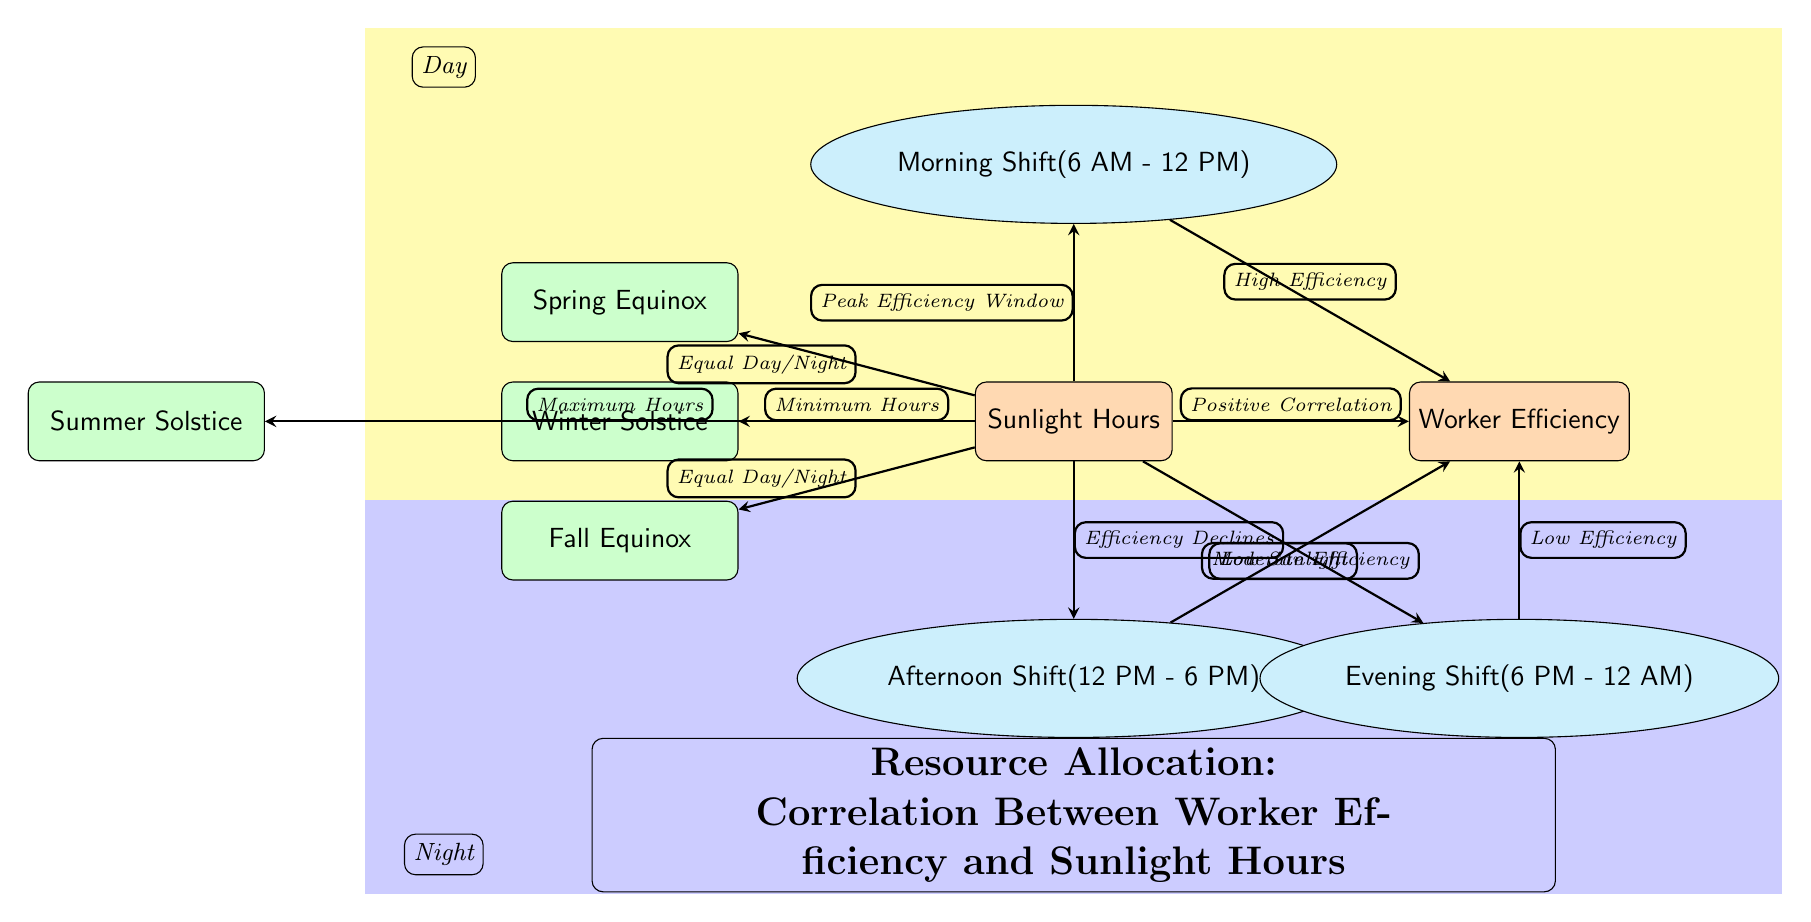What is the relationship between sunlight hours and worker efficiency? The diagram indicates a "Positive Correlation" between sunlight hours and worker efficiency through the arrow connecting the two main nodes.
Answer: Positive Correlation Which shift is associated with high efficiency? The morning shift, represented by the specific node "Morning Shift (6 AM - 12 PM)," connects to the efficiency node with a label indicating "High Efficiency."
Answer: High Efficiency What time frame corresponds to the evening shift? The diagram identifies the evening shift as "Evening Shift (6 PM - 12 AM)," which is represented as a node below the efficiency node.
Answer: 6 PM - 12 AM How does worker efficiency change from morning to afternoon shifts? The diagram shows that worker efficiency is at "High Efficiency" during the morning shift, while it is described as "Moderate Efficiency" for the afternoon shift, indicated by the corresponding arrows connecting these nodes to efficiency.
Answer: Moderate Efficiency Which season is indicated as having minimum sunlight hours? The winter solstice is depicted as having "Minimum Hours," which is conveyed through an arrow that links sunlight to the winter season node.
Answer: Winter Solstice What does the afternoon shift lead to in terms of efficiency? The afternoon shift connects to the worker efficiency node with the label "Moderate Efficiency," indicating how productivity is affected during that shift.
Answer: Moderate Efficiency Which shift experiences low efficiency? The evening shift is connected to the worker efficiency node with the label "Low Efficiency," demonstrating its impact on productivity compared to other shifts.
Answer: Low Efficiency What is indicated about sunlight hours during the summer solstice? The maximum sunlight hours are associated with the summer solstice node, as per the arrow connecting sunlight to that specific seasonal node.
Answer: Maximum Hours What does the diagram suggest about shift scheduling in relation to sunlight hours? The diagram illustrates that to optimize worker efficiency, shifts should ideally align with peak sunlight hours; specifically, the morning shift is recommended due to its high efficiency rating.
Answer: Align shifts with peak sunlight hours 